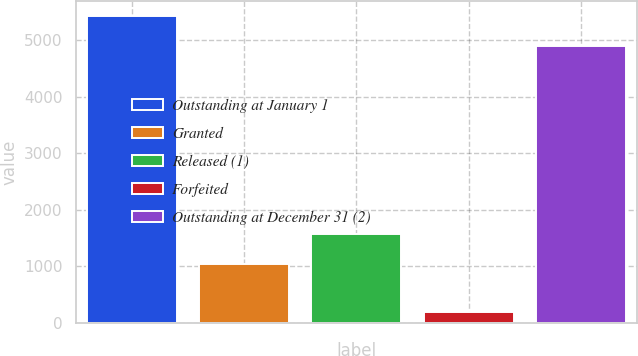Convert chart to OTSL. <chart><loc_0><loc_0><loc_500><loc_500><bar_chart><fcel>Outstanding at January 1<fcel>Granted<fcel>Released (1)<fcel>Forfeited<fcel>Outstanding at December 31 (2)<nl><fcel>5427.5<fcel>1044<fcel>1563.5<fcel>199<fcel>4908<nl></chart> 